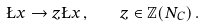<formula> <loc_0><loc_0><loc_500><loc_500>\L x \to z \L x \, , \quad z \in \mathbb { Z } ( N _ { C } ) \, .</formula> 